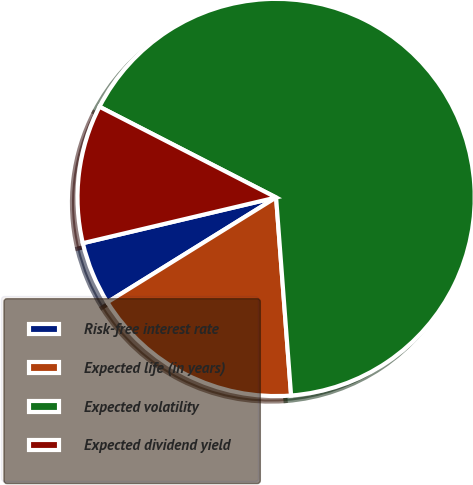Convert chart. <chart><loc_0><loc_0><loc_500><loc_500><pie_chart><fcel>Risk-free interest rate<fcel>Expected life (in years)<fcel>Expected volatility<fcel>Expected dividend yield<nl><fcel>5.15%<fcel>17.36%<fcel>66.25%<fcel>11.25%<nl></chart> 